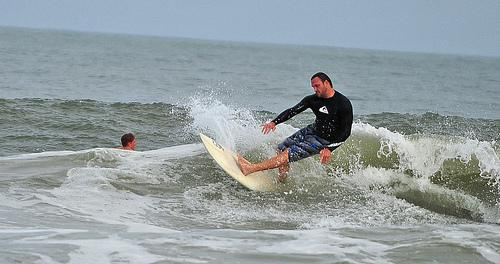Question: who is surfing?
Choices:
A. A young boy.
B. A woman.
C. A little girl.
D. Man.
Answer with the letter. Answer: D Question: why are the waves choppy?
Choices:
A. The boat just passed.
B. There is a storm.
C. Wind.
D. Children are splashing.
Answer with the letter. Answer: C Question: what is blue?
Choices:
A. The sky.
B. Pants.
C. The water.
D. The surfboard.
Answer with the letter. Answer: B Question: what is under the man's feet?
Choices:
A. Grass.
B. Surfboard.
C. Skateboard.
D. Dirg.
Answer with the letter. Answer: B Question: what is black?
Choices:
A. Shirt.
B. The bicycle.
C. The car.
D. Jeans.
Answer with the letter. Answer: A Question: how is the water?
Choices:
A. Calm.
B. Rough.
C. Wavy.
D. Choppy.
Answer with the letter. Answer: C 